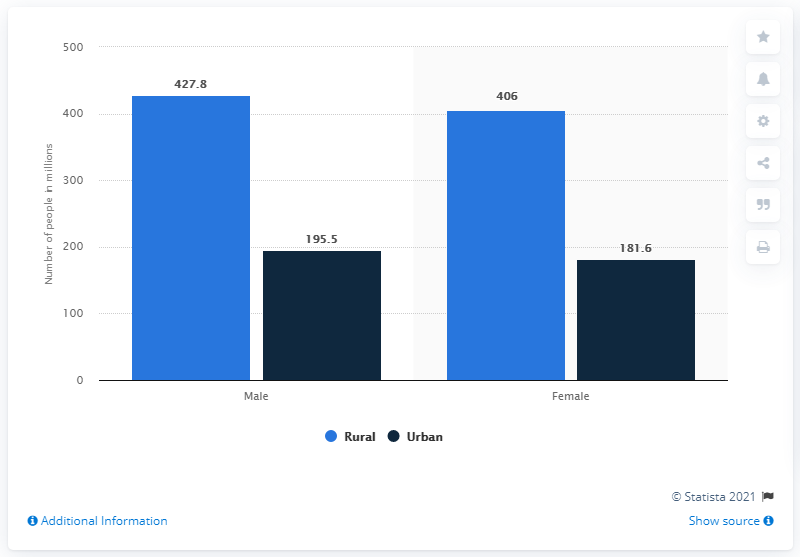Highlight a few significant elements in this photo. The difference between the shortest light blue bar and the tallest dark blue bar is 210.5. In 2011, there were 406 females living in rural areas. The highest urban population among males and females is 195.5. In 2011, there were 427.8 males living in rural areas. 